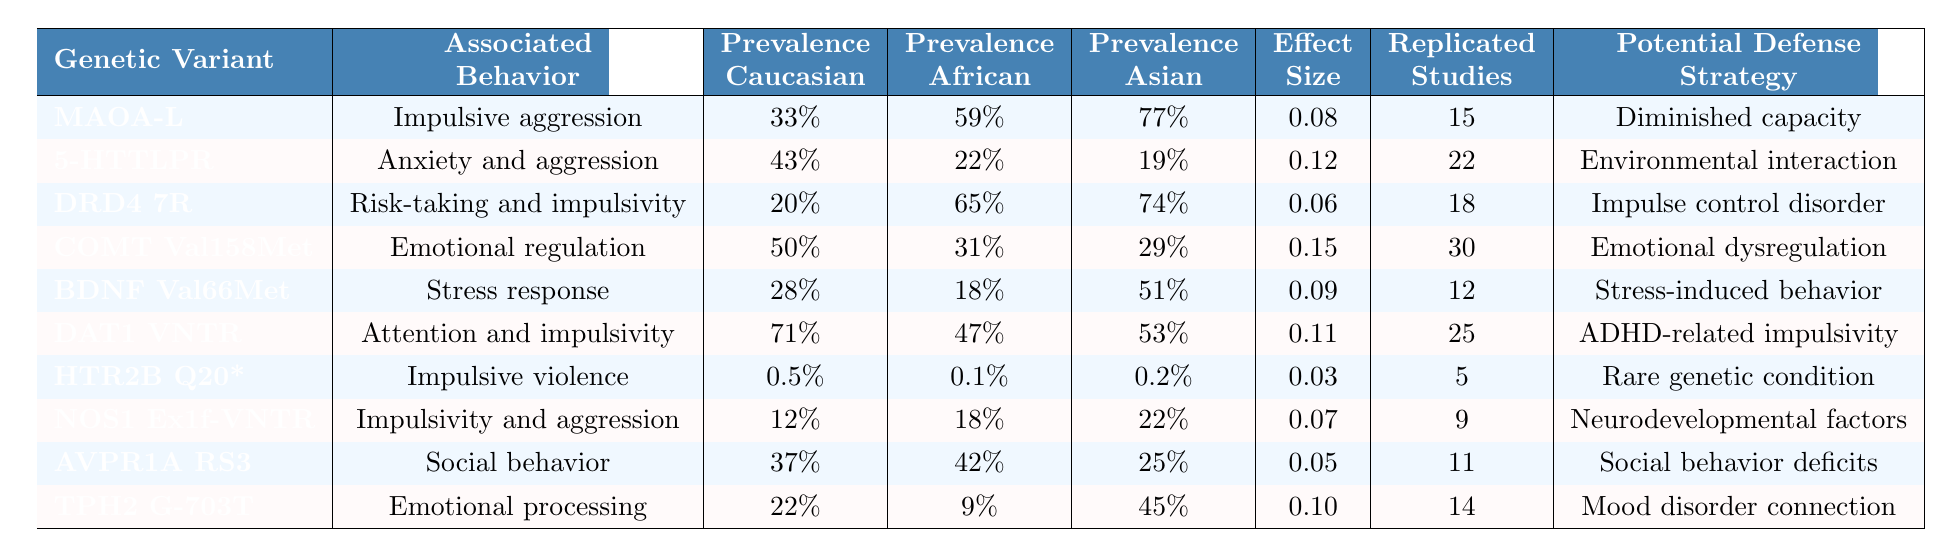What genetic variant is associated with impulsive aggression? The table states that the genetic variant associated with impulsive aggression is MAOA-L.
Answer: MAOA-L What is the prevalence of the 5-HTTLPR variant in the Asian population? According to the table, the prevalence of the 5-HTTLPR variant in the Asian population is 19%.
Answer: 19% Which genetic variant has the highest prevalence among Caucasians? By checking the prevalence column for Caucasians, DAT1 VNTR has the highest prevalence at 71%.
Answer: DAT1 VNTR How many replicated studies are there for the COMT Val158Met variant? The table indicates that there were 30 replicated studies for the COMT Val158Met variant.
Answer: 30 Which associated behavior is linked to the HTR2B Q20* variant? The table reveals that impulsive violence is the associated behavior linked to the HTR2B Q20* variant.
Answer: Impulsive violence What is the effect size of the genetic variant associated with emotional regulation? The effect size for the COMT Val158Met variant, which is associated with emotional regulation, is 0.15.
Answer: 0.15 Does the AVPR1A RS3 variant have a higher prevalence in African populations than in Asian populations? The table shows that the prevalence of AVPR1A RS3 in African populations is 42%, while in Asian populations it is 25%, confirming the statement as true.
Answer: Yes Which genetic variant has the lowest prevalence across all three populations? Checking the prevalence values, the HTR2B Q20* variant has the lowest prevalence, at 0.5% in Caucasians, 0.1% in Africans, and 0.2% in Asians.
Answer: HTR2B Q20* What is the average prevalence of the genetic variants associated with anxiety and aggression across the three populations? The prevalence of the 5-HTTLPR variant for Caucasian, African, and Asian populations is 43%, 22%, and 19% respectively. The average is calculated as (43 + 22 + 19) / 3 = 28. Therefore, the average prevalence is 28%.
Answer: 28% Which potential defense strategy is associated with the genetic variant DRD4 7R? The table indicates that the potential defense strategy associated with the genetic variant DRD4 7R is impulse control disorder.
Answer: Impulse control disorder What is the difference in prevalence of the MAOA-L variant between African and Caucasian populations? The MAOA-L variant prevalence is 59% in Africa and 33% in Caucasia. The difference is 59 - 33 = 26%.
Answer: 26% 